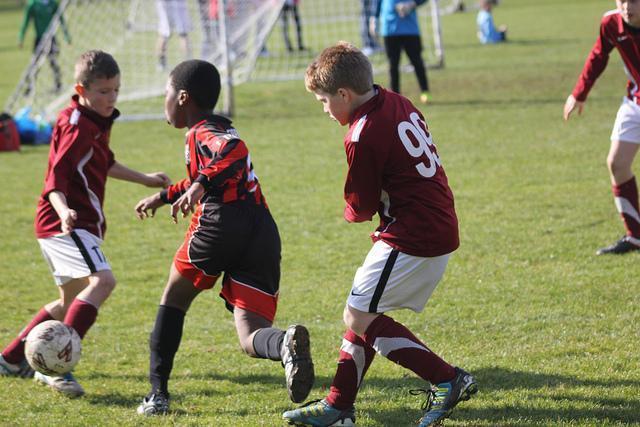How many team members with the yellow shirts can be seen?
Give a very brief answer. 0. How many people are in the photo?
Give a very brief answer. 6. 